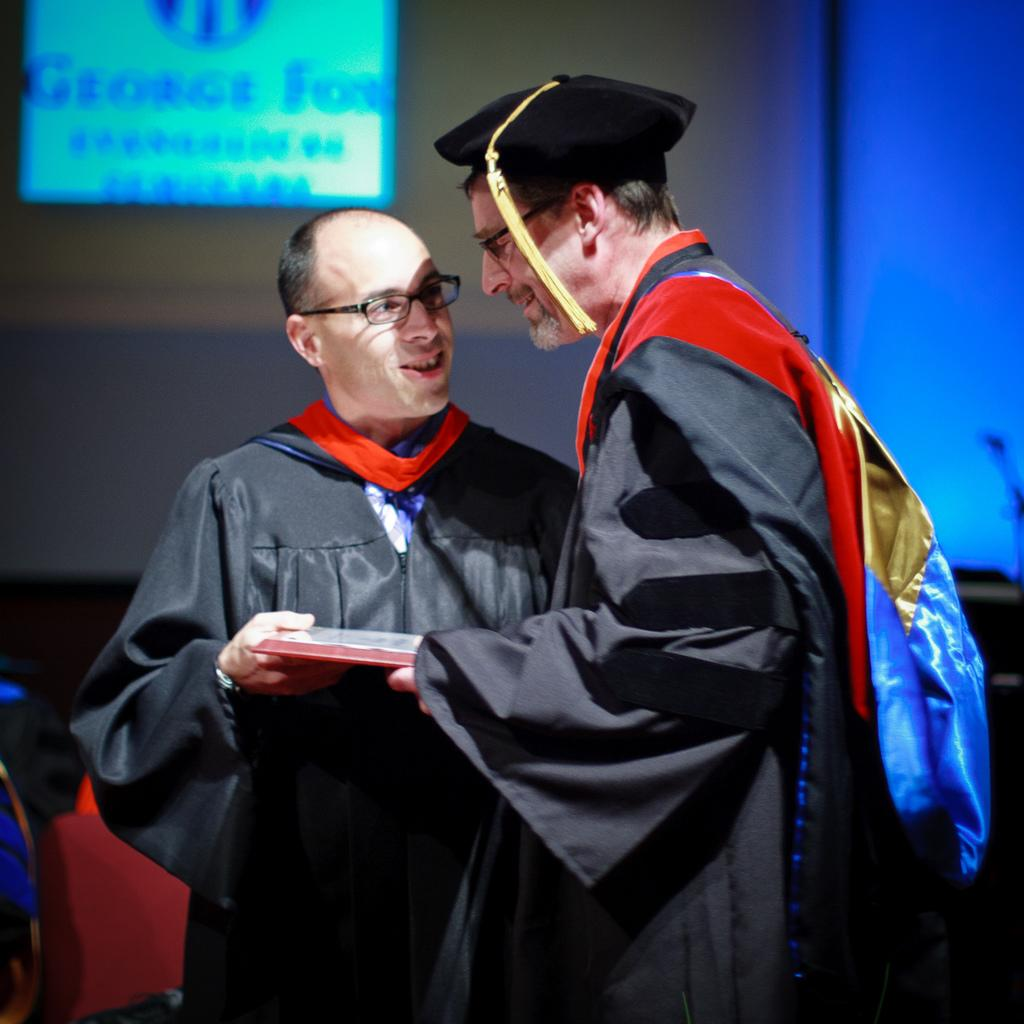Who is present in the image? There is a man in the image. What is the man doing in the image? The man is giving an object to another man. What can be seen in the background of the image? There is a screen in the image. How many clovers can be seen on the screen in the image? There are no clovers visible on the screen in the image. What type of sky is depicted on the screen in the image? There is no sky depicted on the screen in the image. 